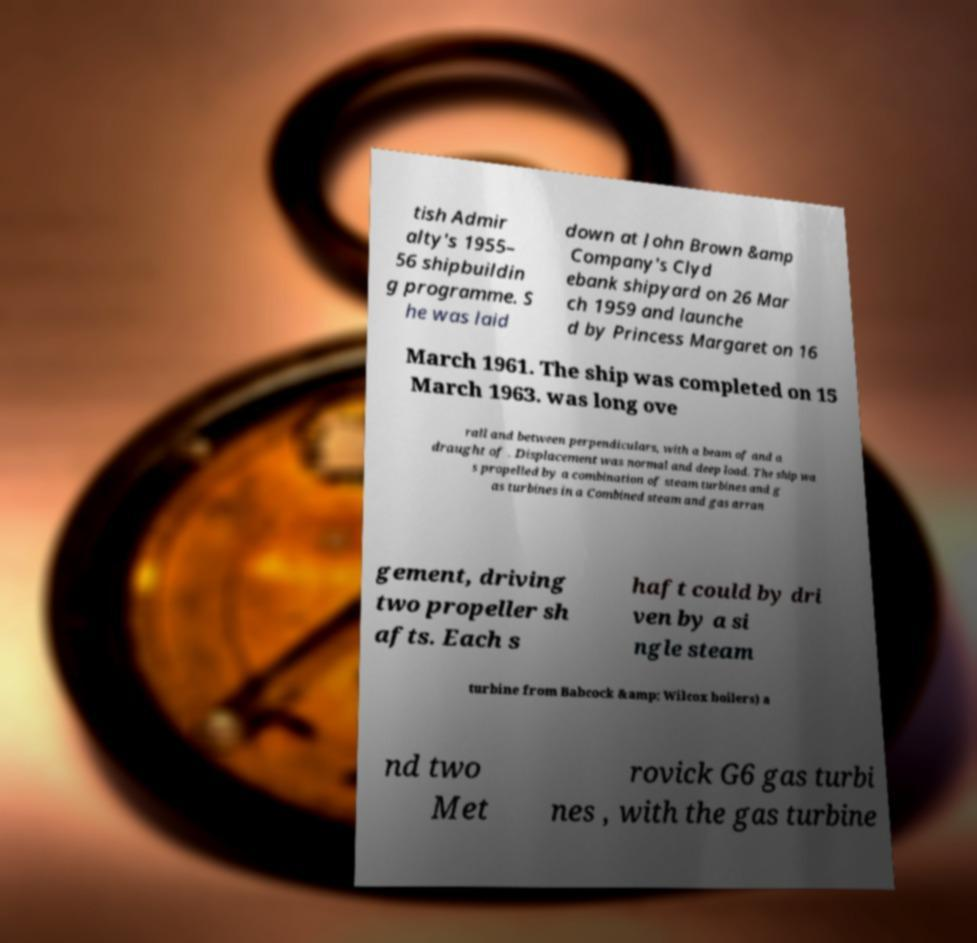Can you accurately transcribe the text from the provided image for me? tish Admir alty's 1955– 56 shipbuildin g programme. S he was laid down at John Brown &amp Company's Clyd ebank shipyard on 26 Mar ch 1959 and launche d by Princess Margaret on 16 March 1961. The ship was completed on 15 March 1963. was long ove rall and between perpendiculars, with a beam of and a draught of . Displacement was normal and deep load. The ship wa s propelled by a combination of steam turbines and g as turbines in a Combined steam and gas arran gement, driving two propeller sh afts. Each s haft could by dri ven by a si ngle steam turbine from Babcock &amp; Wilcox boilers) a nd two Met rovick G6 gas turbi nes , with the gas turbine 